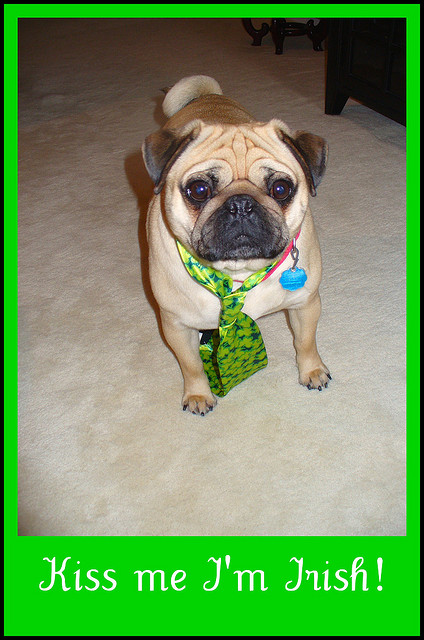Read all the text in this image. Kiss me Irish J'm 